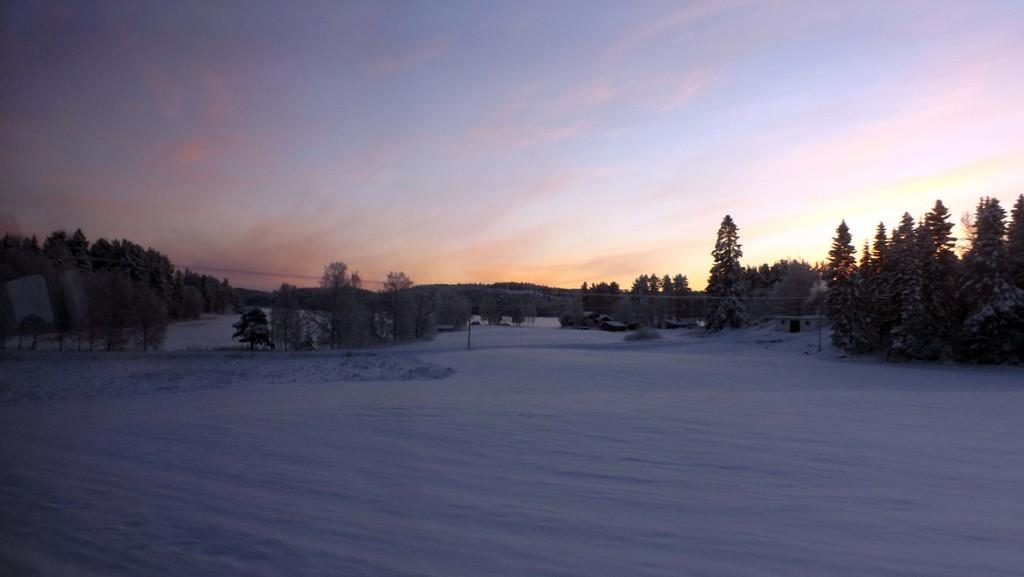What is covering the ground in the image? There is snow on the ground in the image. What structures can be seen in the image? There are poles, houses, and trees visible in the image. What type of objects are present in the image? There are objects in the image, but their specific nature is not mentioned in the facts. What is visible in the sky in the image? There are clouds in the sky in the image. What type of vessel is being used by the doctor in the image? There is no vessel or doctor present in the image; it features snow on the ground, poles, houses, trees, and unspecified objects. 